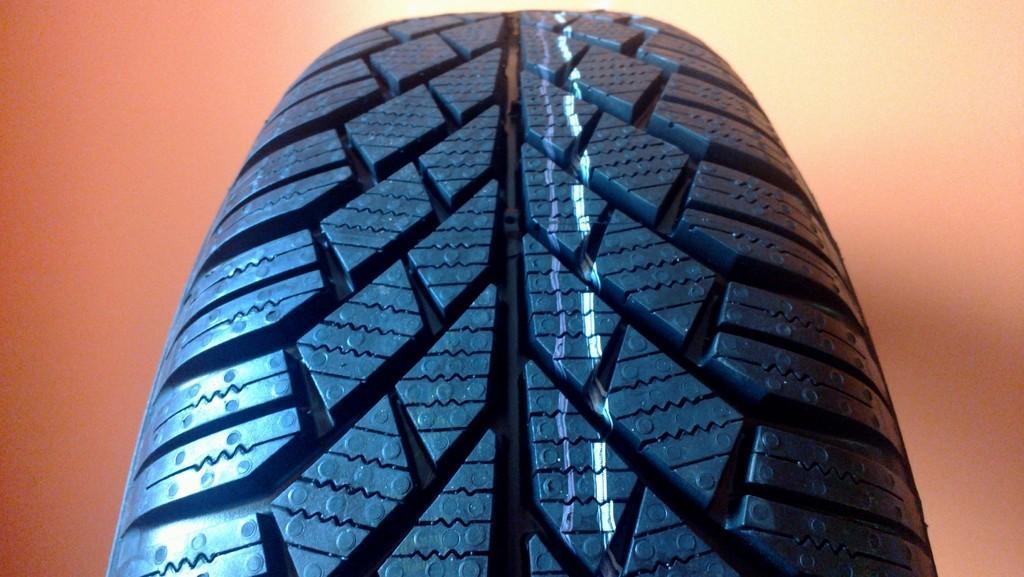How would you summarize this image in a sentence or two? In this picture I can see the tire in front which is of black in color. 